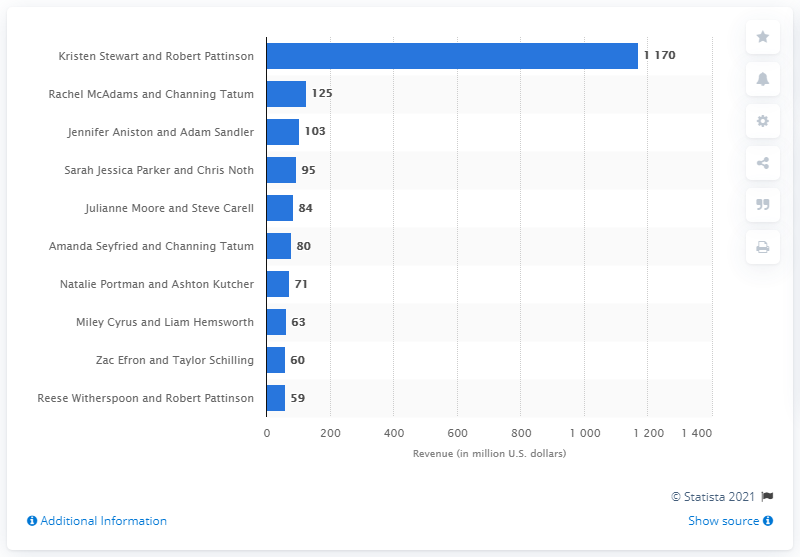Indicate a few pertinent items in this graphic. In 2013, Kristen Stewart and Robert Pattinson were the top grossing couple. The total revenue of Twilight was 1170. 